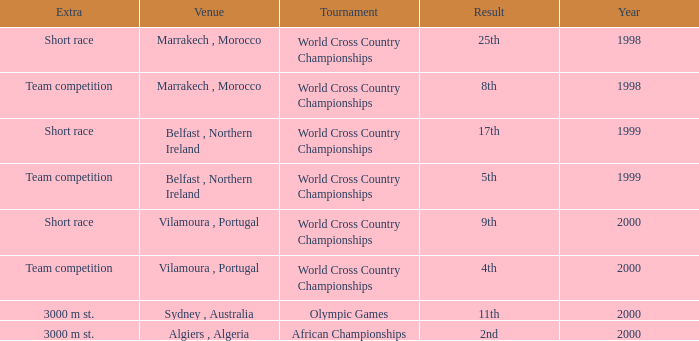Could you parse the entire table as a dict? {'header': ['Extra', 'Venue', 'Tournament', 'Result', 'Year'], 'rows': [['Short race', 'Marrakech , Morocco', 'World Cross Country Championships', '25th', '1998'], ['Team competition', 'Marrakech , Morocco', 'World Cross Country Championships', '8th', '1998'], ['Short race', 'Belfast , Northern Ireland', 'World Cross Country Championships', '17th', '1999'], ['Team competition', 'Belfast , Northern Ireland', 'World Cross Country Championships', '5th', '1999'], ['Short race', 'Vilamoura , Portugal', 'World Cross Country Championships', '9th', '2000'], ['Team competition', 'Vilamoura , Portugal', 'World Cross Country Championships', '4th', '2000'], ['3000 m st.', 'Sydney , Australia', 'Olympic Games', '11th', '2000'], ['3000 m st.', 'Algiers , Algeria', 'African Championships', '2nd', '2000']]} Tell me the extra for tournament of olympic games 3000 m st. 